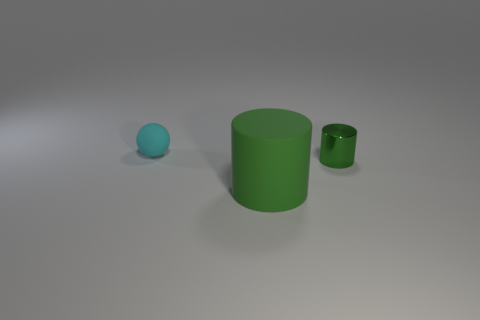Are there more rubber things that are to the right of the green shiny thing than green metal things that are left of the small rubber thing?
Your response must be concise. No. There is a cyan thing that is made of the same material as the large cylinder; what size is it?
Provide a succinct answer. Small. What size is the green cylinder right of the cylinder in front of the cylinder that is right of the large green object?
Provide a short and direct response. Small. What is the color of the matte object in front of the tiny ball?
Your answer should be compact. Green. Is the number of tiny green metal objects in front of the green rubber cylinder greater than the number of green matte objects?
Provide a short and direct response. No. There is a green thing that is left of the tiny cylinder; does it have the same shape as the small cyan rubber object?
Provide a succinct answer. No. What number of blue things are either balls or tiny metallic cylinders?
Your answer should be very brief. 0. Is the number of small yellow balls greater than the number of tiny cyan spheres?
Make the answer very short. No. There is a object that is the same size as the cyan sphere; what is its color?
Offer a very short reply. Green. What number of cubes are either small cyan objects or tiny objects?
Your answer should be compact. 0. 